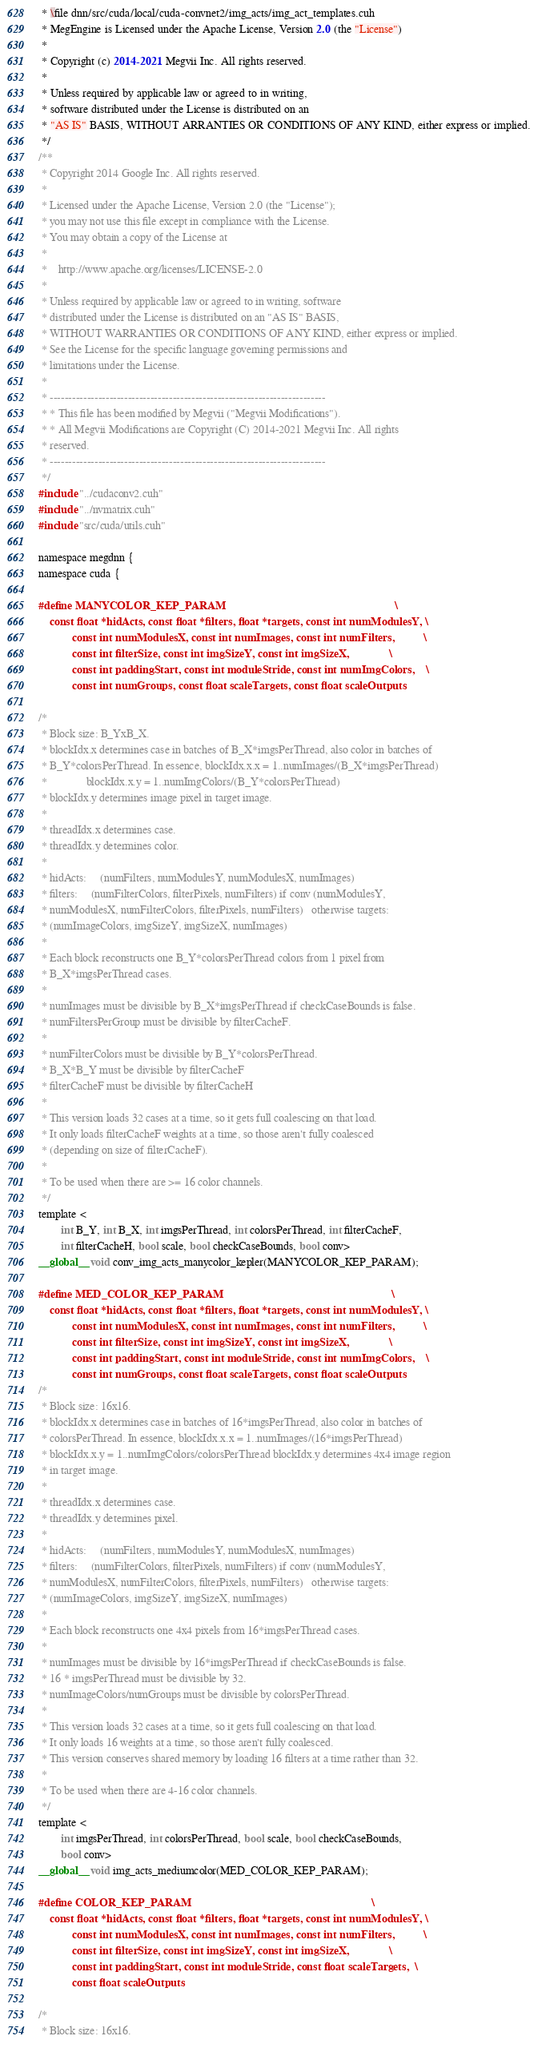Convert code to text. <code><loc_0><loc_0><loc_500><loc_500><_Cuda_> * \file dnn/src/cuda/local/cuda-convnet2/img_acts/img_act_templates.cuh
 * MegEngine is Licensed under the Apache License, Version 2.0 (the "License")
 *
 * Copyright (c) 2014-2021 Megvii Inc. All rights reserved.
 *
 * Unless required by applicable law or agreed to in writing,
 * software distributed under the License is distributed on an
 * "AS IS" BASIS, WITHOUT ARRANTIES OR CONDITIONS OF ANY KIND, either express or implied.
 */
/**
 * Copyright 2014 Google Inc. All rights reserved.
 *
 * Licensed under the Apache License, Version 2.0 (the "License");
 * you may not use this file except in compliance with the License.
 * You may obtain a copy of the License at
 *
 *    http://www.apache.org/licenses/LICENSE-2.0
 *
 * Unless required by applicable law or agreed to in writing, software
 * distributed under the License is distributed on an "AS IS" BASIS,
 * WITHOUT WARRANTIES OR CONDITIONS OF ANY KIND, either express or implied.
 * See the License for the specific language governing permissions and
 * limitations under the License.
 *
 * --------------------------------------------------------------------------
 * * This file has been modified by Megvii ("Megvii Modifications").
 * * All Megvii Modifications are Copyright (C) 2014-2021 Megvii Inc. All rights
 * reserved.
 * --------------------------------------------------------------------------
 */
#include "../cudaconv2.cuh"
#include "../nvmatrix.cuh"
#include "src/cuda/utils.cuh"

namespace megdnn {
namespace cuda {

#define MANYCOLOR_KEP_PARAM                                                            \
    const float *hidActs, const float *filters, float *targets, const int numModulesY, \
            const int numModulesX, const int numImages, const int numFilters,          \
            const int filterSize, const int imgSizeY, const int imgSizeX,              \
            const int paddingStart, const int moduleStride, const int numImgColors,    \
            const int numGroups, const float scaleTargets, const float scaleOutputs

/*
 * Block size: B_YxB_X.
 * blockIdx.x determines case in batches of B_X*imgsPerThread, also color in batches of
 * B_Y*colorsPerThread. In essence, blockIdx.x.x = 1..numImages/(B_X*imgsPerThread)
 *              blockIdx.x.y = 1..numImgColors/(B_Y*colorsPerThread)
 * blockIdx.y determines image pixel in target image.
 *
 * threadIdx.x determines case.
 * threadIdx.y determines color.
 *
 * hidActs:     (numFilters, numModulesY, numModulesX, numImages)
 * filters:     (numFilterColors, filterPixels, numFilters) if conv (numModulesY,
 * numModulesX, numFilterColors, filterPixels, numFilters)   otherwise targets:
 * (numImageColors, imgSizeY, imgSizeX, numImages)
 *
 * Each block reconstructs one B_Y*colorsPerThread colors from 1 pixel from
 * B_X*imgsPerThread cases.
 *
 * numImages must be divisible by B_X*imgsPerThread if checkCaseBounds is false.
 * numFiltersPerGroup must be divisible by filterCacheF.
 *
 * numFilterColors must be divisible by B_Y*colorsPerThread.
 * B_X*B_Y must be divisible by filterCacheF
 * filterCacheF must be divisible by filterCacheH
 *
 * This version loads 32 cases at a time, so it gets full coalescing on that load.
 * It only loads filterCacheF weights at a time, so those aren't fully coalesced
 * (depending on size of filterCacheF).
 *
 * To be used when there are >= 16 color channels.
 */
template <
        int B_Y, int B_X, int imgsPerThread, int colorsPerThread, int filterCacheF,
        int filterCacheH, bool scale, bool checkCaseBounds, bool conv>
__global__ void conv_img_acts_manycolor_kepler(MANYCOLOR_KEP_PARAM);

#define MED_COLOR_KEP_PARAM                                                            \
    const float *hidActs, const float *filters, float *targets, const int numModulesY, \
            const int numModulesX, const int numImages, const int numFilters,          \
            const int filterSize, const int imgSizeY, const int imgSizeX,              \
            const int paddingStart, const int moduleStride, const int numImgColors,    \
            const int numGroups, const float scaleTargets, const float scaleOutputs
/*
 * Block size: 16x16.
 * blockIdx.x determines case in batches of 16*imgsPerThread, also color in batches of
 * colorsPerThread. In essence, blockIdx.x.x = 1..numImages/(16*imgsPerThread)
 * blockIdx.x.y = 1..numImgColors/colorsPerThread blockIdx.y determines 4x4 image region
 * in target image.
 *
 * threadIdx.x determines case.
 * threadIdx.y determines pixel.
 *
 * hidActs:     (numFilters, numModulesY, numModulesX, numImages)
 * filters:     (numFilterColors, filterPixels, numFilters) if conv (numModulesY,
 * numModulesX, numFilterColors, filterPixels, numFilters)   otherwise targets:
 * (numImageColors, imgSizeY, imgSizeX, numImages)
 *
 * Each block reconstructs one 4x4 pixels from 16*imgsPerThread cases.
 *
 * numImages must be divisible by 16*imgsPerThread if checkCaseBounds is false.
 * 16 * imgsPerThread must be divisible by 32.
 * numImageColors/numGroups must be divisible by colorsPerThread.
 *
 * This version loads 32 cases at a time, so it gets full coalescing on that load.
 * It only loads 16 weights at a time, so those aren't fully coalesced.
 * This version conserves shared memory by loading 16 filters at a time rather than 32.
 *
 * To be used when there are 4-16 color channels.
 */
template <
        int imgsPerThread, int colorsPerThread, bool scale, bool checkCaseBounds,
        bool conv>
__global__ void img_acts_mediumcolor(MED_COLOR_KEP_PARAM);

#define COLOR_KEP_PARAM                                                                \
    const float *hidActs, const float *filters, float *targets, const int numModulesY, \
            const int numModulesX, const int numImages, const int numFilters,          \
            const int filterSize, const int imgSizeY, const int imgSizeX,              \
            const int paddingStart, const int moduleStride, const float scaleTargets,  \
            const float scaleOutputs

/*
 * Block size: 16x16.</code> 